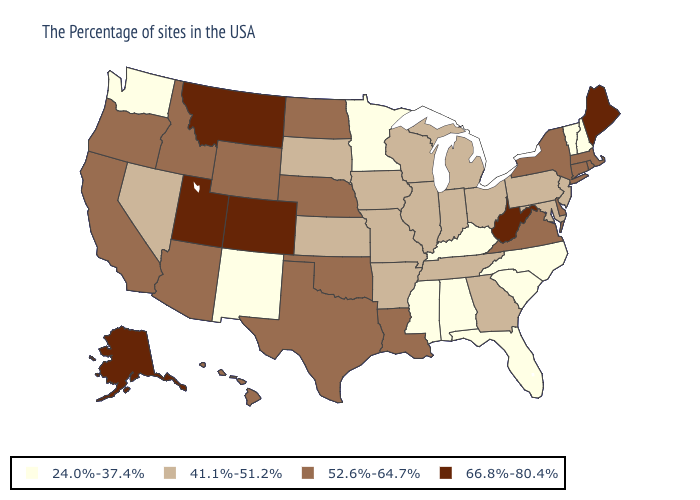What is the lowest value in states that border North Dakota?
Keep it brief. 24.0%-37.4%. What is the highest value in the USA?
Concise answer only. 66.8%-80.4%. Among the states that border Arkansas , which have the highest value?
Answer briefly. Louisiana, Oklahoma, Texas. Which states have the lowest value in the USA?
Short answer required. New Hampshire, Vermont, North Carolina, South Carolina, Florida, Kentucky, Alabama, Mississippi, Minnesota, New Mexico, Washington. Name the states that have a value in the range 24.0%-37.4%?
Be succinct. New Hampshire, Vermont, North Carolina, South Carolina, Florida, Kentucky, Alabama, Mississippi, Minnesota, New Mexico, Washington. Does the map have missing data?
Quick response, please. No. Does Indiana have the lowest value in the MidWest?
Be succinct. No. Name the states that have a value in the range 24.0%-37.4%?
Quick response, please. New Hampshire, Vermont, North Carolina, South Carolina, Florida, Kentucky, Alabama, Mississippi, Minnesota, New Mexico, Washington. What is the lowest value in the West?
Concise answer only. 24.0%-37.4%. Name the states that have a value in the range 41.1%-51.2%?
Write a very short answer. New Jersey, Maryland, Pennsylvania, Ohio, Georgia, Michigan, Indiana, Tennessee, Wisconsin, Illinois, Missouri, Arkansas, Iowa, Kansas, South Dakota, Nevada. Among the states that border Minnesota , does North Dakota have the highest value?
Keep it brief. Yes. Name the states that have a value in the range 52.6%-64.7%?
Quick response, please. Massachusetts, Rhode Island, Connecticut, New York, Delaware, Virginia, Louisiana, Nebraska, Oklahoma, Texas, North Dakota, Wyoming, Arizona, Idaho, California, Oregon, Hawaii. Name the states that have a value in the range 66.8%-80.4%?
Be succinct. Maine, West Virginia, Colorado, Utah, Montana, Alaska. Name the states that have a value in the range 52.6%-64.7%?
Short answer required. Massachusetts, Rhode Island, Connecticut, New York, Delaware, Virginia, Louisiana, Nebraska, Oklahoma, Texas, North Dakota, Wyoming, Arizona, Idaho, California, Oregon, Hawaii. Name the states that have a value in the range 52.6%-64.7%?
Concise answer only. Massachusetts, Rhode Island, Connecticut, New York, Delaware, Virginia, Louisiana, Nebraska, Oklahoma, Texas, North Dakota, Wyoming, Arizona, Idaho, California, Oregon, Hawaii. 